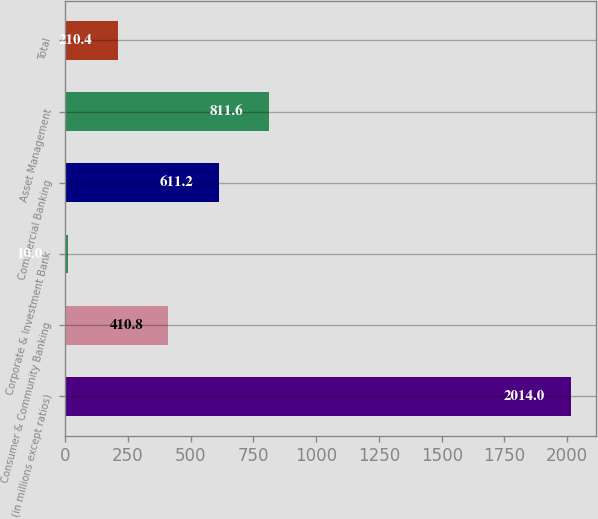Convert chart. <chart><loc_0><loc_0><loc_500><loc_500><bar_chart><fcel>(in millions except ratios)<fcel>Consumer & Community Banking<fcel>Corporate & Investment Bank<fcel>Commercial Banking<fcel>Asset Management<fcel>Total<nl><fcel>2014<fcel>410.8<fcel>10<fcel>611.2<fcel>811.6<fcel>210.4<nl></chart> 